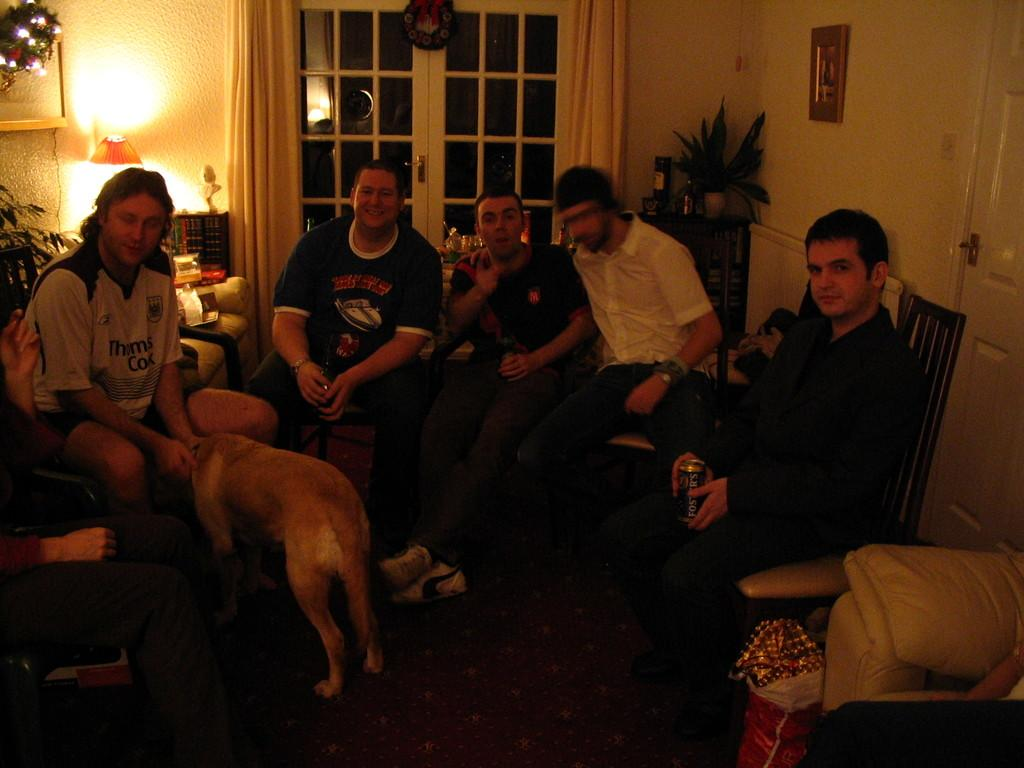What are the people in the image doing? The people in the image are sitting on chairs. What type of animal can be seen in the image? A dog is present in the image. Can you describe the lighting source in the image? There is a lamp on the wall in the image. What is the main architectural feature in the middle of the image? There is a glass window in the middle of the image. What is the name of the person sitting on the chair in the image? The provided facts do not include any names, so it is impossible to determine the name of the person sitting on the chair in the image. Can you tell me how many drums are visible in the image? There are no drums present in the image. 